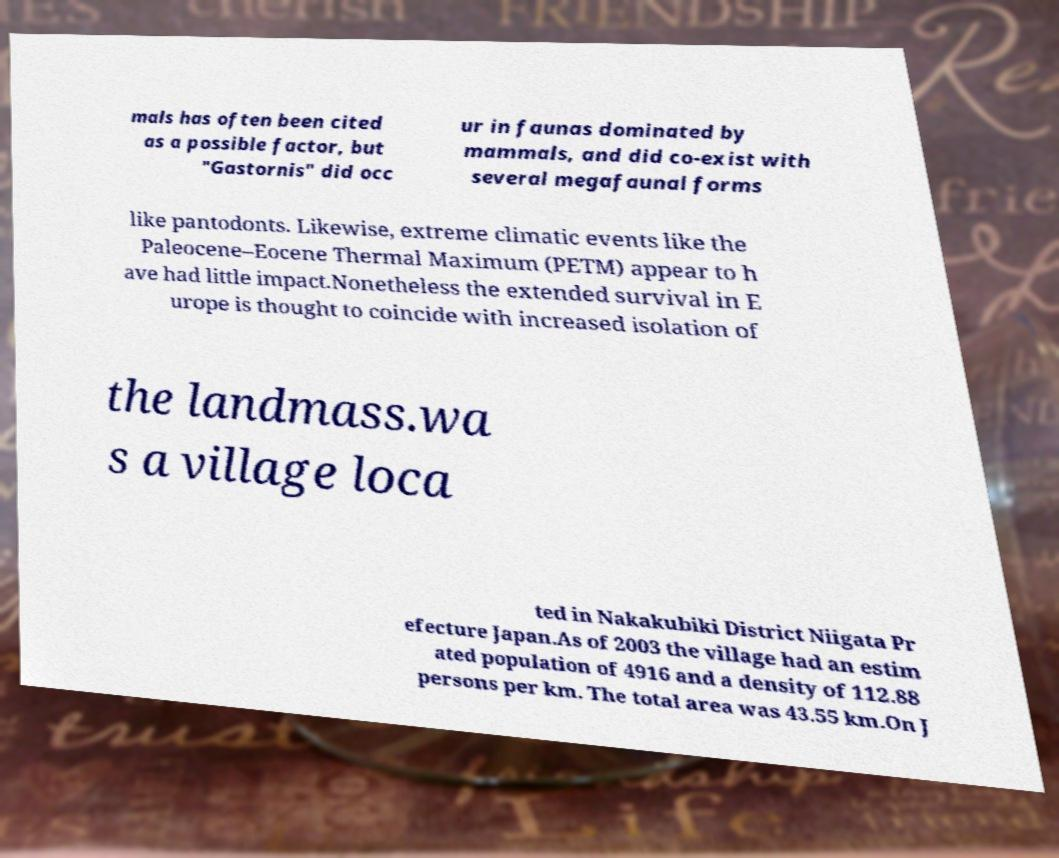Could you extract and type out the text from this image? mals has often been cited as a possible factor, but "Gastornis" did occ ur in faunas dominated by mammals, and did co-exist with several megafaunal forms like pantodonts. Likewise, extreme climatic events like the Paleocene–Eocene Thermal Maximum (PETM) appear to h ave had little impact.Nonetheless the extended survival in E urope is thought to coincide with increased isolation of the landmass.wa s a village loca ted in Nakakubiki District Niigata Pr efecture Japan.As of 2003 the village had an estim ated population of 4916 and a density of 112.88 persons per km. The total area was 43.55 km.On J 